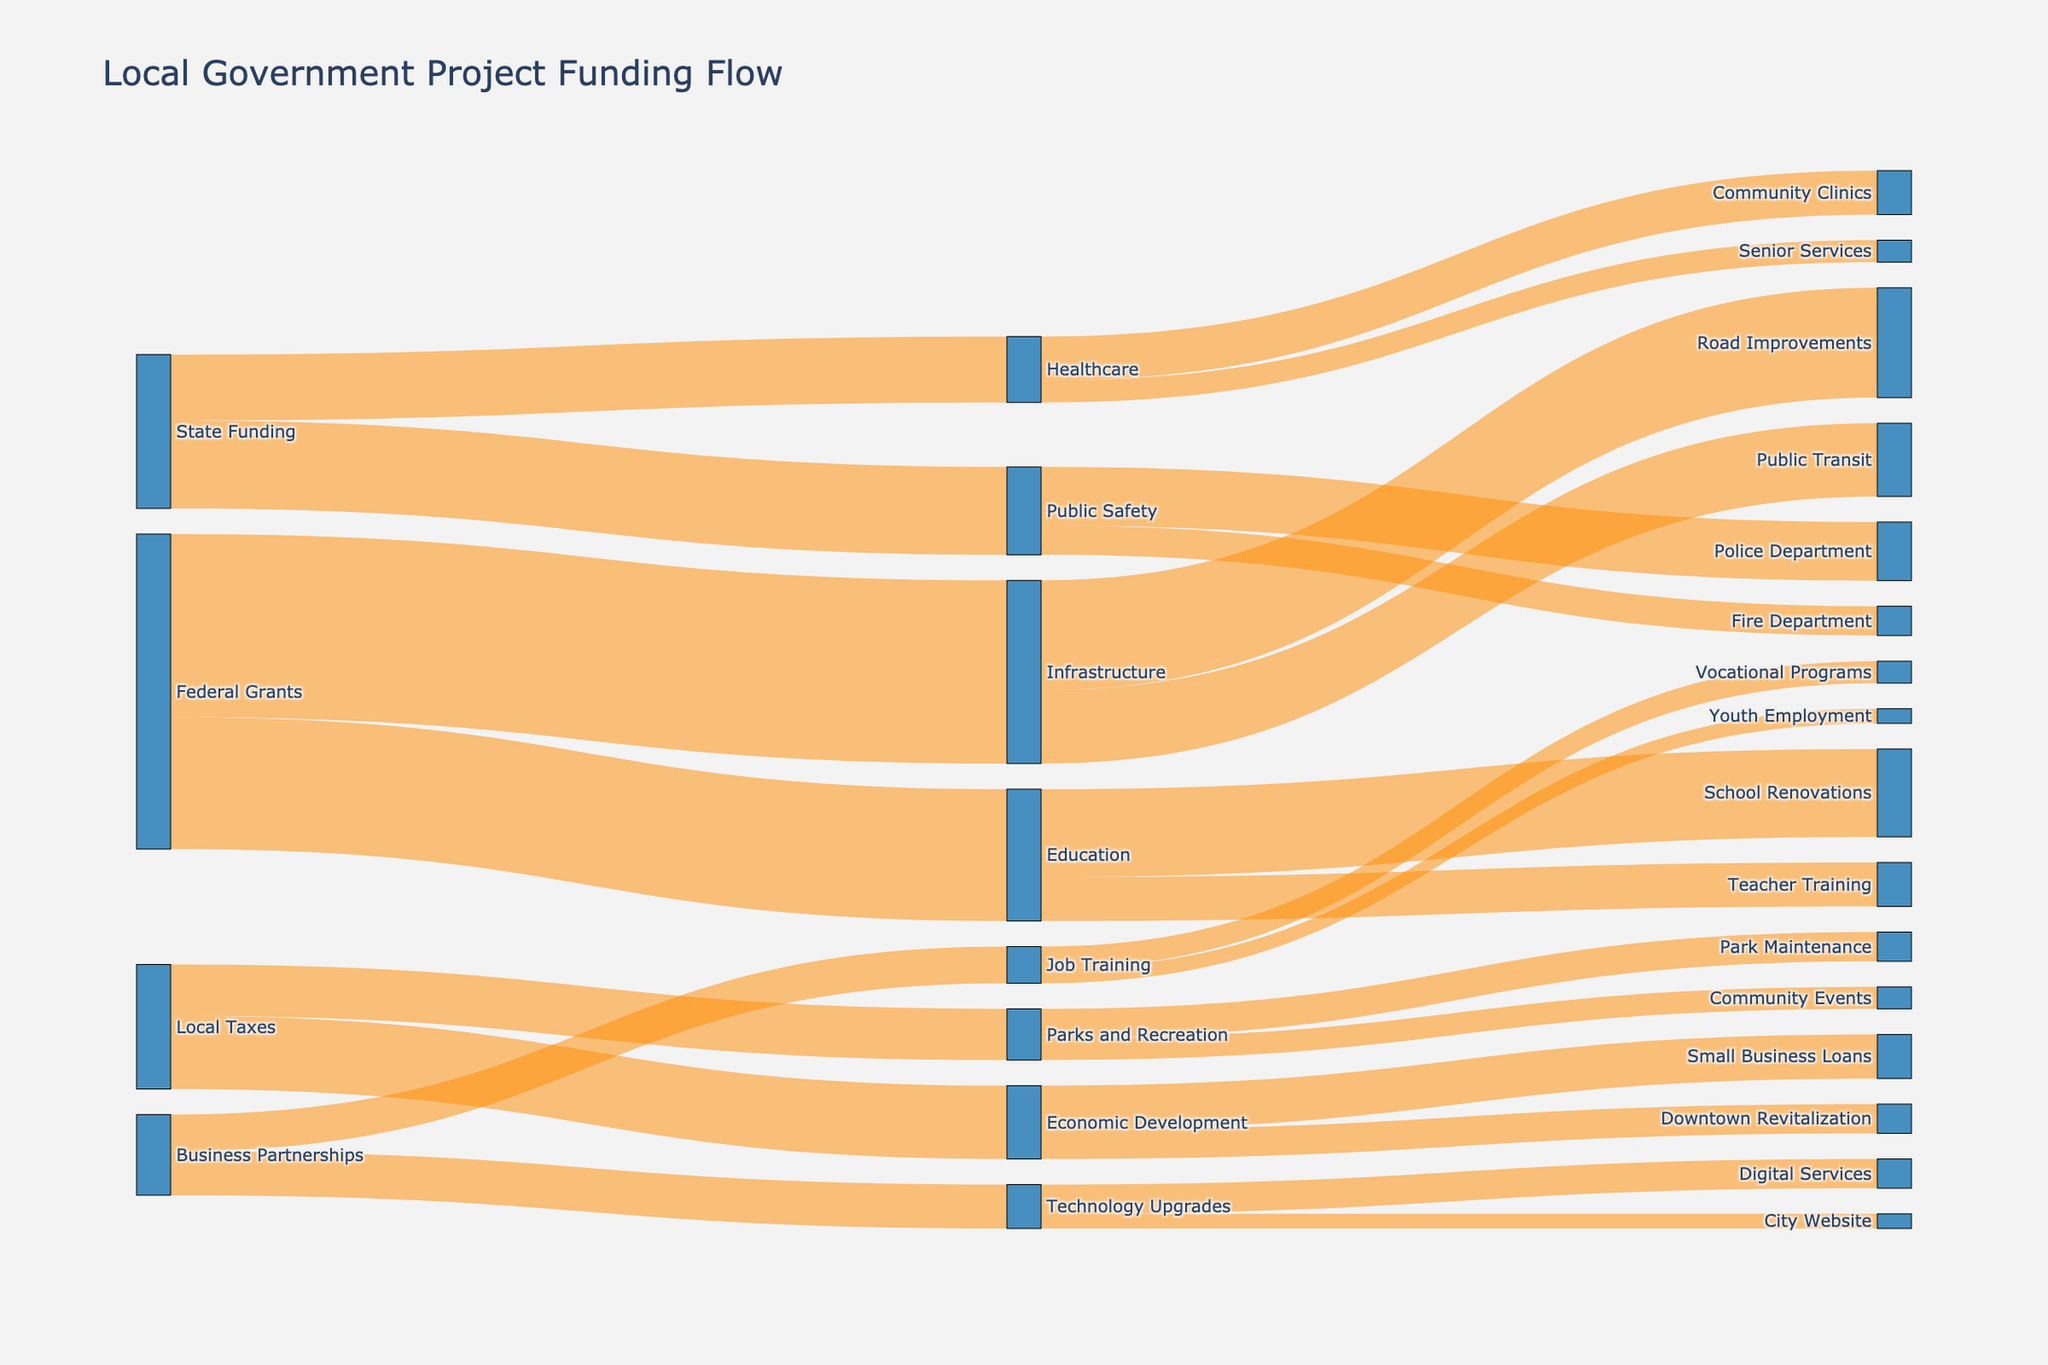What is the main title of this Sankey Diagram? To find the main title, look at the top of the figure where the title is usually positioned. The main title is often meant to give a brief explanation of what the diagram represents.
Answer: Local Government Project Funding Flow Which funding source allocates the most funds to infrastructure? Compare all the funding sources connected to "Infrastructure" by looking at the widths of the streams (links) in the diagram. The source with the widest stream allocates the most funds to infrastructure.
Answer: Federal Grants 